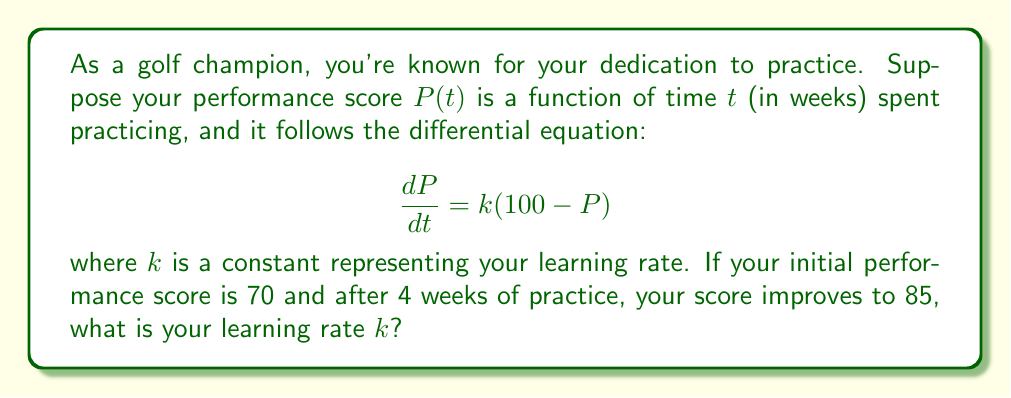Can you solve this math problem? Let's approach this step-by-step:

1) We're given a first-order linear differential equation:

   $$\frac{dP}{dt} = k(100 - P)$$

2) This is a separable equation. We can solve it as follows:

   $$\frac{dP}{100 - P} = k dt$$

3) Integrating both sides:

   $$-\ln|100 - P| = kt + C$$

4) Solving for $P$:

   $$P = 100 - Ae^{-kt}$$

   where $A$ is a constant of integration.

5) We're given two conditions:
   - At $t = 0$, $P = 70$
   - At $t = 4$, $P = 85$

6) Using the initial condition:

   $70 = 100 - A$
   $A = 30$

7) Now our equation is:

   $$P = 100 - 30e^{-kt}$$

8) Using the second condition:

   $$85 = 100 - 30e^{-4k}$$

9) Solving for $k$:

   $$30e^{-4k} = 15$$
   $$e^{-4k} = \frac{1}{2}$$
   $$-4k = \ln(\frac{1}{2}) = -\ln(2)$$
   $$k = \frac{\ln(2)}{4} \approx 0.1733$$

Therefore, your learning rate $k$ is approximately 0.1733 per week.
Answer: $k \approx 0.1733$ per week 